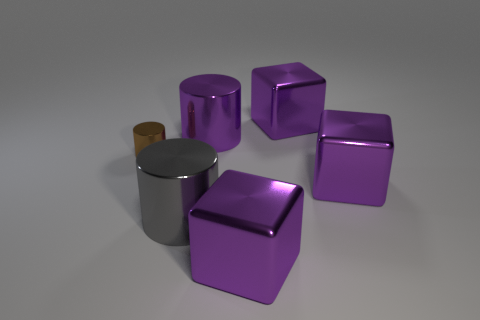Subtract all brown metallic cylinders. How many cylinders are left? 2 Add 1 small red cylinders. How many objects exist? 7 Subtract all brown cylinders. How many cylinders are left? 2 Subtract 2 cubes. How many cubes are left? 1 Subtract all red cylinders. Subtract all purple cubes. How many cylinders are left? 3 Subtract all purple blocks. How many yellow cylinders are left? 0 Subtract all large purple metal cubes. Subtract all gray things. How many objects are left? 2 Add 5 large purple cylinders. How many large purple cylinders are left? 6 Add 6 matte balls. How many matte balls exist? 6 Subtract 0 red balls. How many objects are left? 6 